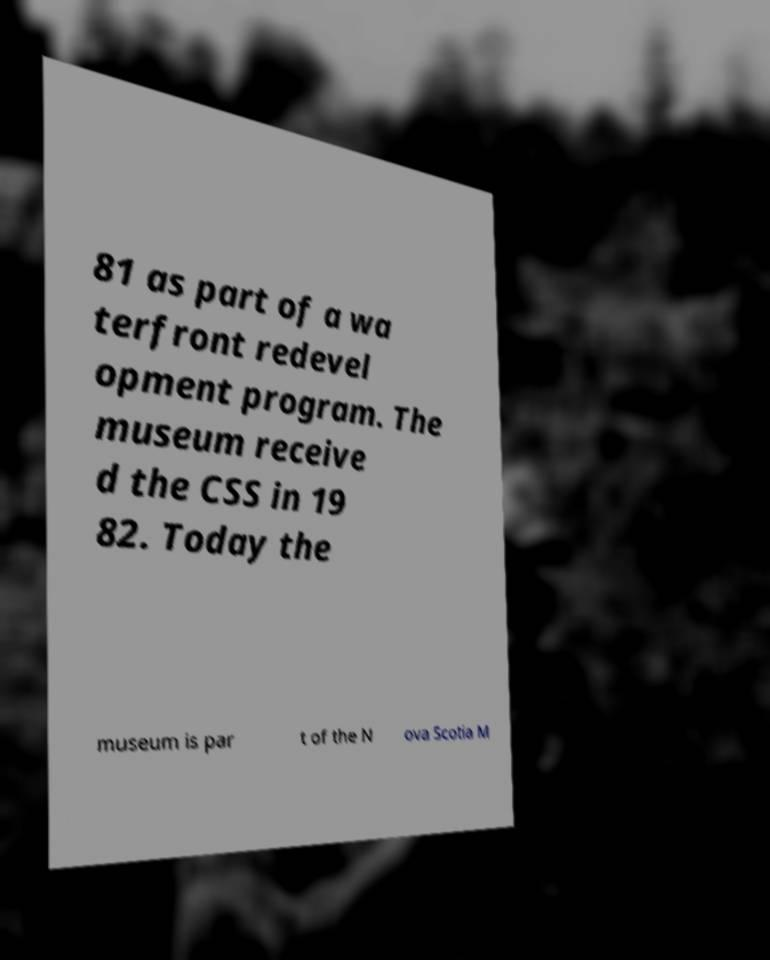Can you accurately transcribe the text from the provided image for me? 81 as part of a wa terfront redevel opment program. The museum receive d the CSS in 19 82. Today the museum is par t of the N ova Scotia M 